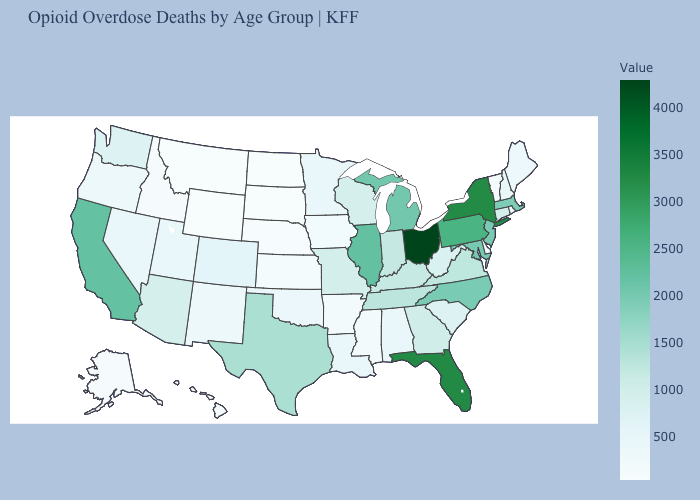Among the states that border Washington , does Oregon have the highest value?
Concise answer only. Yes. Does the map have missing data?
Be succinct. No. Does the map have missing data?
Short answer required. No. Among the states that border Connecticut , which have the lowest value?
Concise answer only. Rhode Island. Does Hawaii have the lowest value in the West?
Quick response, please. No. 